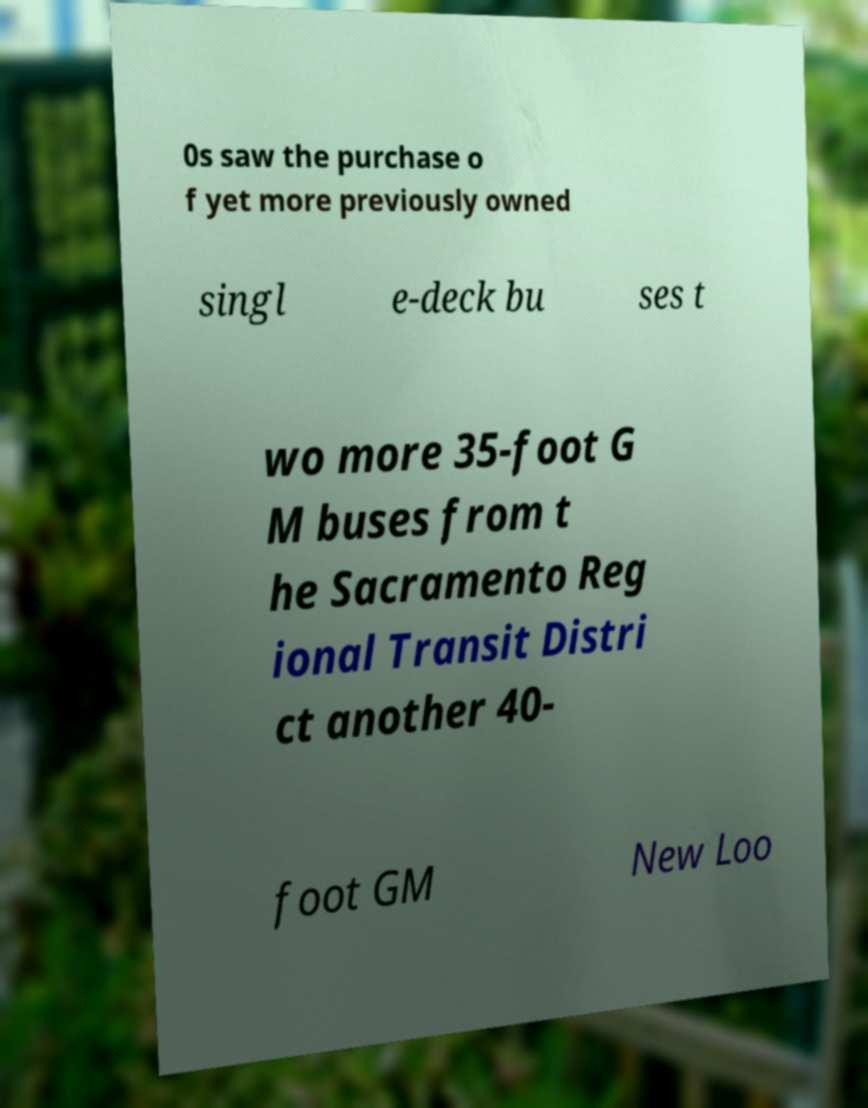There's text embedded in this image that I need extracted. Can you transcribe it verbatim? 0s saw the purchase o f yet more previously owned singl e-deck bu ses t wo more 35-foot G M buses from t he Sacramento Reg ional Transit Distri ct another 40- foot GM New Loo 